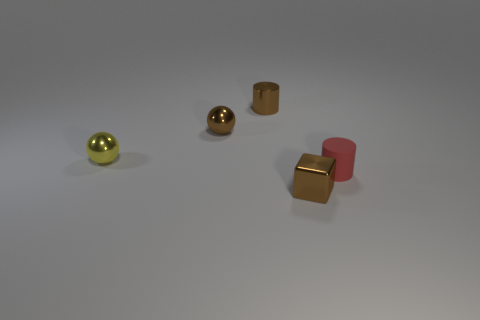The yellow metal object that is the same size as the red rubber cylinder is what shape?
Offer a very short reply. Sphere. What number of things are purple objects or small metallic things that are behind the red rubber cylinder?
Offer a terse response. 3. Are the tiny cylinder behind the small matte object and the small ball in front of the small brown metal sphere made of the same material?
Make the answer very short. Yes. What number of red things are objects or rubber objects?
Give a very brief answer. 1. Is the number of objects in front of the tiny matte object greater than the number of large cyan things?
Keep it short and to the point. Yes. There is a small red rubber cylinder; what number of brown metallic cylinders are to the left of it?
Give a very brief answer. 1. Are there any metallic objects that have the same size as the brown metallic cylinder?
Offer a very short reply. Yes. There is another small object that is the same shape as the matte thing; what is its color?
Keep it short and to the point. Brown. Is the size of the metallic ball that is right of the tiny yellow thing the same as the brown thing in front of the yellow metallic sphere?
Your answer should be compact. Yes. Is there another small object that has the same shape as the red object?
Keep it short and to the point. Yes. 